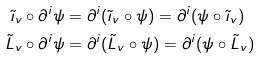Convert formula to latex. <formula><loc_0><loc_0><loc_500><loc_500>\tilde { \imath } _ { v } \circ \partial ^ { i } \psi & = \partial ^ { i } ( \tilde { \imath } _ { v } \circ \psi ) = \partial ^ { i } ( \psi \circ \tilde { \imath } _ { v } ) \\ \tilde { L } _ { v } \circ \partial ^ { i } \psi & = \partial ^ { i } ( \tilde { L } _ { v } \circ \psi ) = \partial ^ { i } ( \psi \circ \tilde { L } _ { v } ) \</formula> 